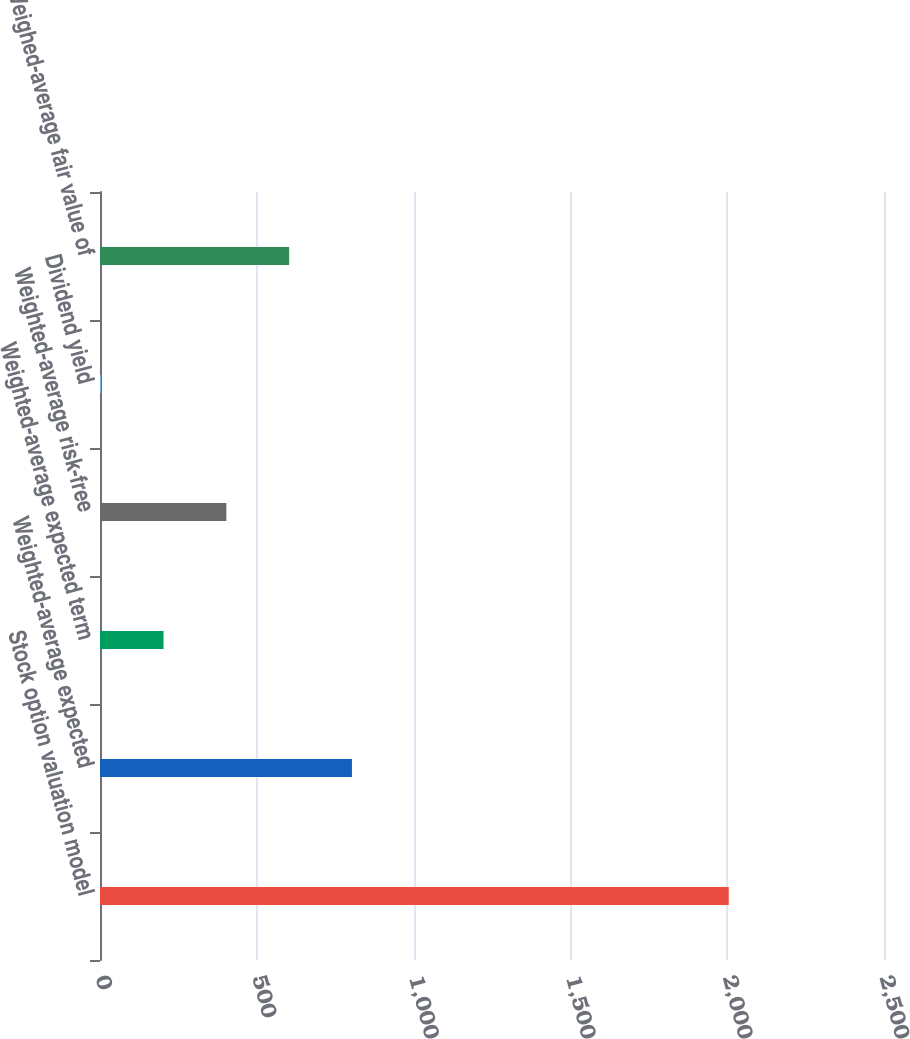Convert chart. <chart><loc_0><loc_0><loc_500><loc_500><bar_chart><fcel>Stock option valuation model<fcel>Weighted-average expected<fcel>Weighted-average expected term<fcel>Weighted-average risk-free<fcel>Dividend yield<fcel>Weighed-average fair value of<nl><fcel>2005<fcel>803.44<fcel>202.66<fcel>402.92<fcel>2.4<fcel>603.18<nl></chart> 